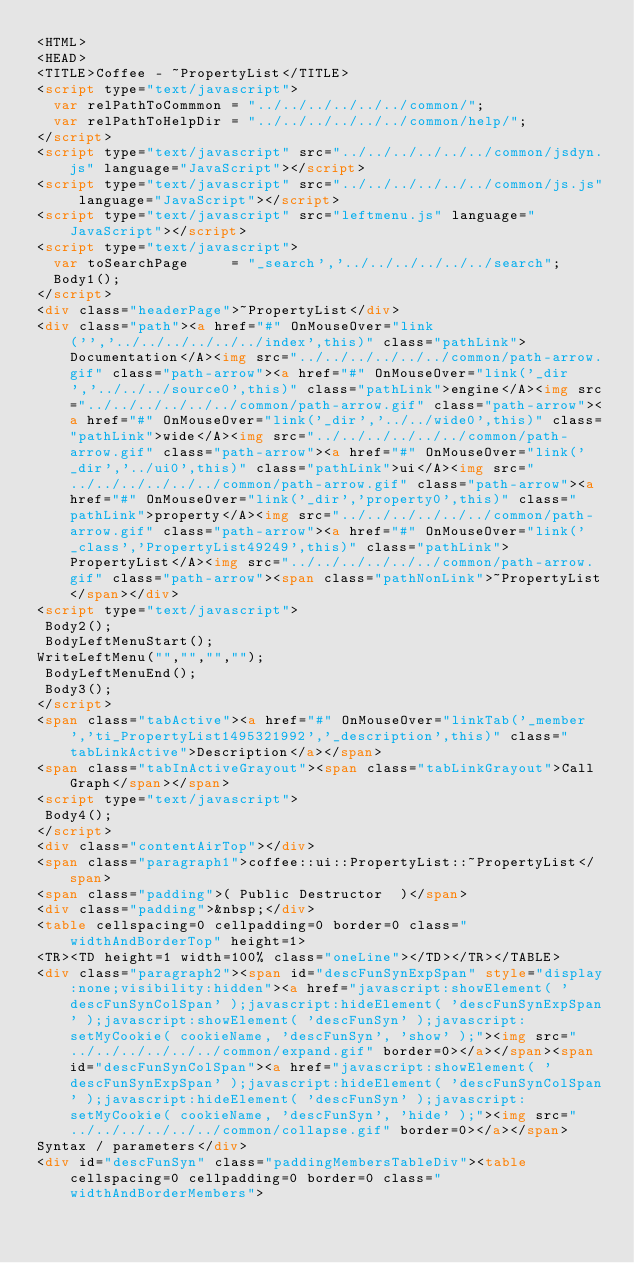<code> <loc_0><loc_0><loc_500><loc_500><_HTML_><HTML>
<HEAD>
<TITLE>Coffee - ~PropertyList</TITLE>
<script type="text/javascript">
  var relPathToCommmon = "../../../../../../common/";
  var relPathToHelpDir = "../../../../../../common/help/";
</script>
<script type="text/javascript" src="../../../../../../common/jsdyn.js" language="JavaScript"></script>
<script type="text/javascript" src="../../../../../../common/js.js" language="JavaScript"></script>
<script type="text/javascript" src="leftmenu.js" language="JavaScript"></script>
<script type="text/javascript">
  var toSearchPage     = "_search','../../../../../../search";
  Body1();
</script>
<div class="headerPage">~PropertyList</div>
<div class="path"><a href="#" OnMouseOver="link('','../../../../../../index',this)" class="pathLink">Documentation</A><img src="../../../../../../common/path-arrow.gif" class="path-arrow"><a href="#" OnMouseOver="link('_dir','../../../source0',this)" class="pathLink">engine</A><img src="../../../../../../common/path-arrow.gif" class="path-arrow"><a href="#" OnMouseOver="link('_dir','../../wide0',this)" class="pathLink">wide</A><img src="../../../../../../common/path-arrow.gif" class="path-arrow"><a href="#" OnMouseOver="link('_dir','../ui0',this)" class="pathLink">ui</A><img src="../../../../../../common/path-arrow.gif" class="path-arrow"><a href="#" OnMouseOver="link('_dir','property0',this)" class="pathLink">property</A><img src="../../../../../../common/path-arrow.gif" class="path-arrow"><a href="#" OnMouseOver="link('_class','PropertyList49249',this)" class="pathLink">PropertyList</A><img src="../../../../../../common/path-arrow.gif" class="path-arrow"><span class="pathNonLink">~PropertyList</span></div>
<script type="text/javascript">
 Body2();
 BodyLeftMenuStart();
WriteLeftMenu("","","","");
 BodyLeftMenuEnd();
 Body3();
</script>
<span class="tabActive"><a href="#" OnMouseOver="linkTab('_member','ti_PropertyList1495321992','_description',this)" class="tabLinkActive">Description</a></span>
<span class="tabInActiveGrayout"><span class="tabLinkGrayout">Call Graph</span></span>
<script type="text/javascript">
 Body4();
</script>
<div class="contentAirTop"></div>
<span class="paragraph1">coffee::ui::PropertyList::~PropertyList</span>
<span class="padding">( Public Destructor  )</span>
<div class="padding">&nbsp;</div>
<table cellspacing=0 cellpadding=0 border=0 class="widthAndBorderTop" height=1>
<TR><TD height=1 width=100% class="oneLine"></TD></TR></TABLE>
<div class="paragraph2"><span id="descFunSynExpSpan" style="display:none;visibility:hidden"><a href="javascript:showElement( 'descFunSynColSpan' );javascript:hideElement( 'descFunSynExpSpan' );javascript:showElement( 'descFunSyn' );javascript:setMyCookie( cookieName, 'descFunSyn', 'show' );"><img src="../../../../../../common/expand.gif" border=0></a></span><span id="descFunSynColSpan"><a href="javascript:showElement( 'descFunSynExpSpan' );javascript:hideElement( 'descFunSynColSpan' );javascript:hideElement( 'descFunSyn' );javascript:setMyCookie( cookieName, 'descFunSyn', 'hide' );"><img src="../../../../../../common/collapse.gif" border=0></a></span>
Syntax / parameters</div>
<div id="descFunSyn" class="paddingMembersTableDiv"><table cellspacing=0 cellpadding=0 border=0 class="widthAndBorderMembers"></code> 